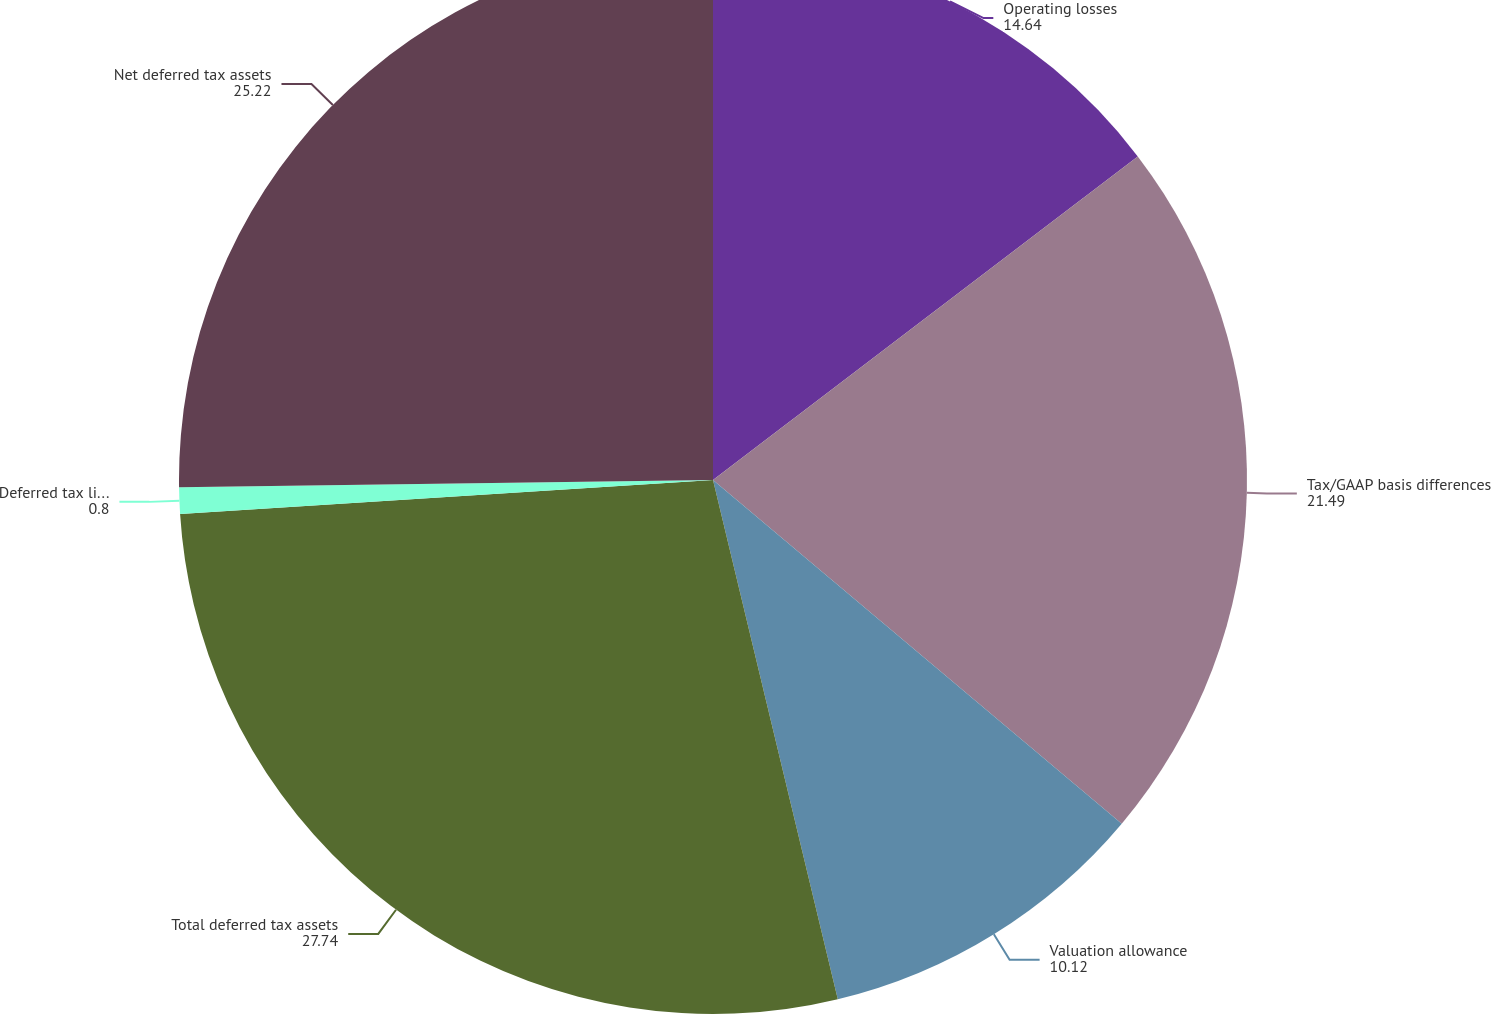<chart> <loc_0><loc_0><loc_500><loc_500><pie_chart><fcel>Operating losses<fcel>Tax/GAAP basis differences<fcel>Valuation allowance<fcel>Total deferred tax assets<fcel>Deferred tax liabilities<fcel>Net deferred tax assets<nl><fcel>14.64%<fcel>21.49%<fcel>10.12%<fcel>27.74%<fcel>0.8%<fcel>25.22%<nl></chart> 